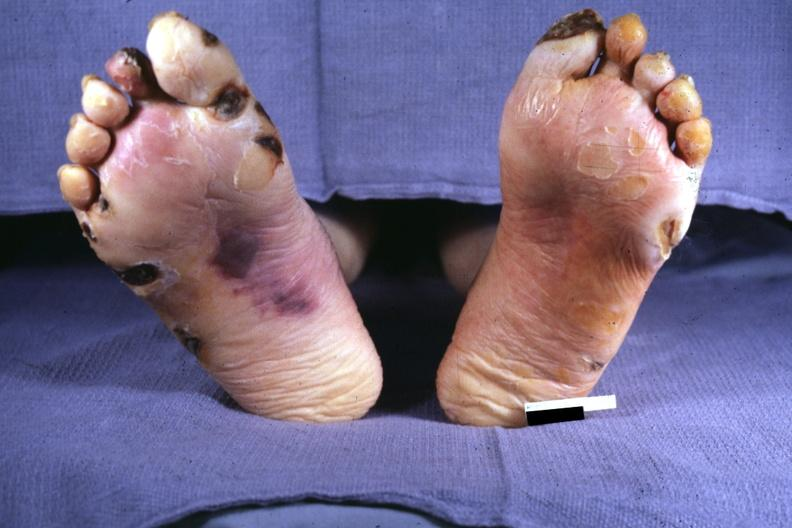s feet present?
Answer the question using a single word or phrase. Yes 